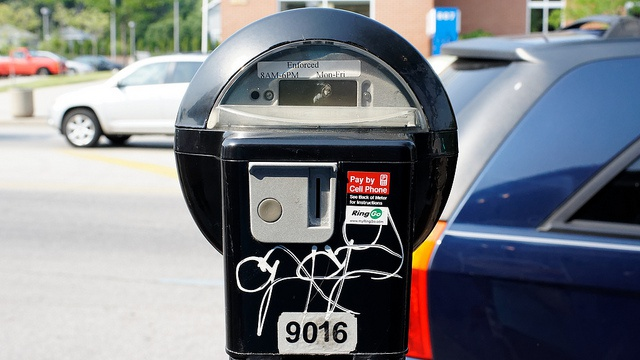Describe the objects in this image and their specific colors. I can see parking meter in darkgreen, black, darkgray, lightgray, and gray tones, car in darkgreen, black, navy, and gray tones, car in darkgreen, white, lightblue, gray, and darkgray tones, truck in darkgreen, lightpink, salmon, and pink tones, and car in darkgreen, lightpink, salmon, and pink tones in this image. 